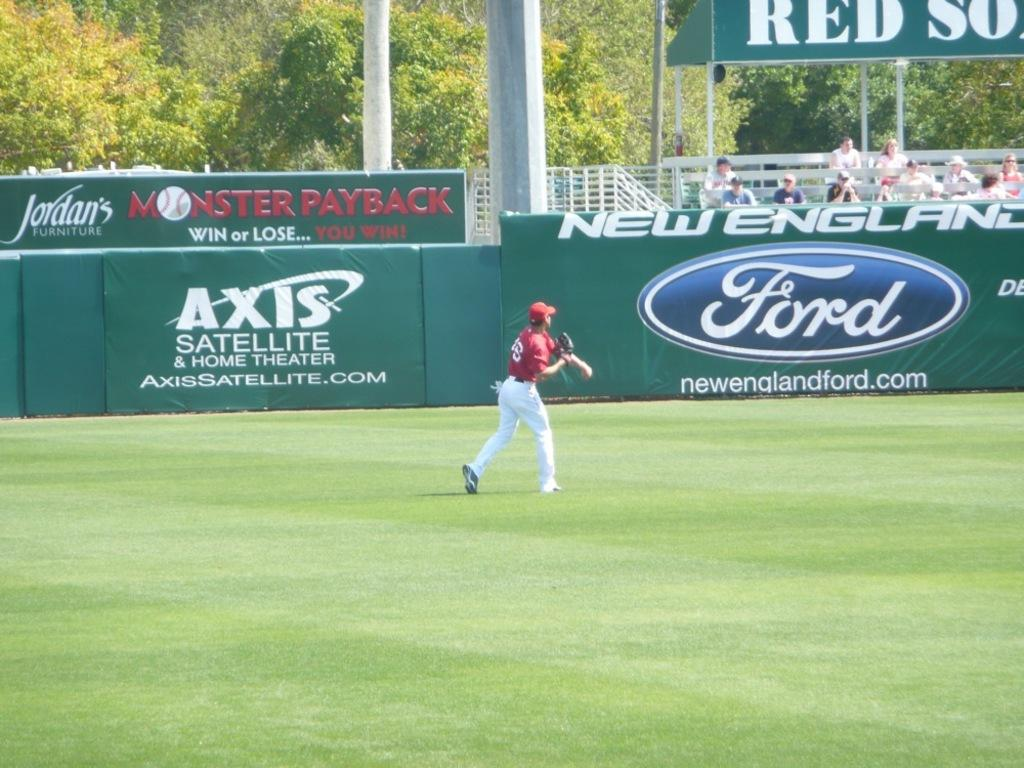<image>
Describe the image concisely. a person throwing a ball with the word Ford on a wall 